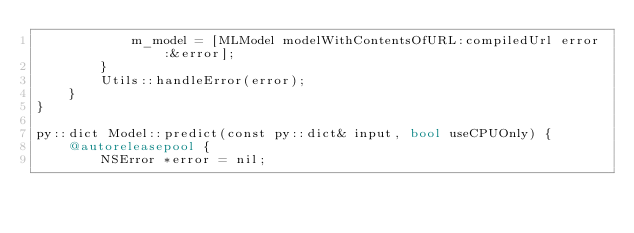<code> <loc_0><loc_0><loc_500><loc_500><_ObjectiveC_>            m_model = [MLModel modelWithContentsOfURL:compiledUrl error:&error];
        }
        Utils::handleError(error);
    }
}

py::dict Model::predict(const py::dict& input, bool useCPUOnly) {
    @autoreleasepool {
        NSError *error = nil;</code> 